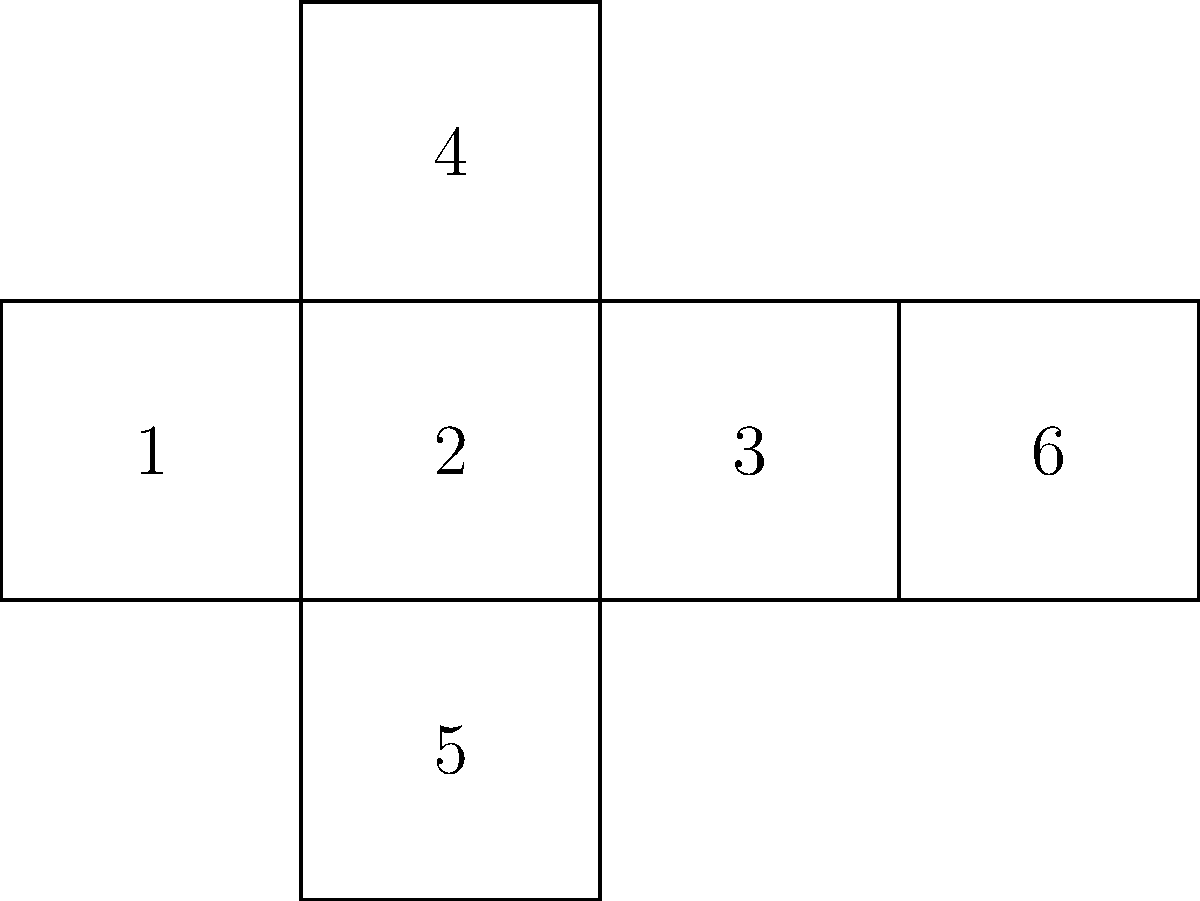As an entrepreneur in Ghana, you're designing a unique packaging for your product. The package needs to be a cube, and you're working on the unfolded net. Which face in the unfolded net will be opposite to face 2 when the cube is folded? To solve this problem, we need to mentally fold the net into a cube and identify the opposite faces. Let's follow these steps:

1. Observe that face 2 is in the center of the net.
2. The faces adjacent to face 2 are 1, 3, 4, and 5.
3. When folded, these adjacent faces will form the sides of the cube that share an edge with face 2.
4. The only remaining face that isn't adjacent to face 2 is face 6.
5. In a cube, opposite faces are those that don't share any edges.
6. Therefore, when the net is folded into a cube, face 6 will be opposite to face 2.

This spatial reasoning is crucial in package design, as it allows you to plan the layout of your product information and branding elements effectively on the cube-shaped package.
Answer: Face 6 